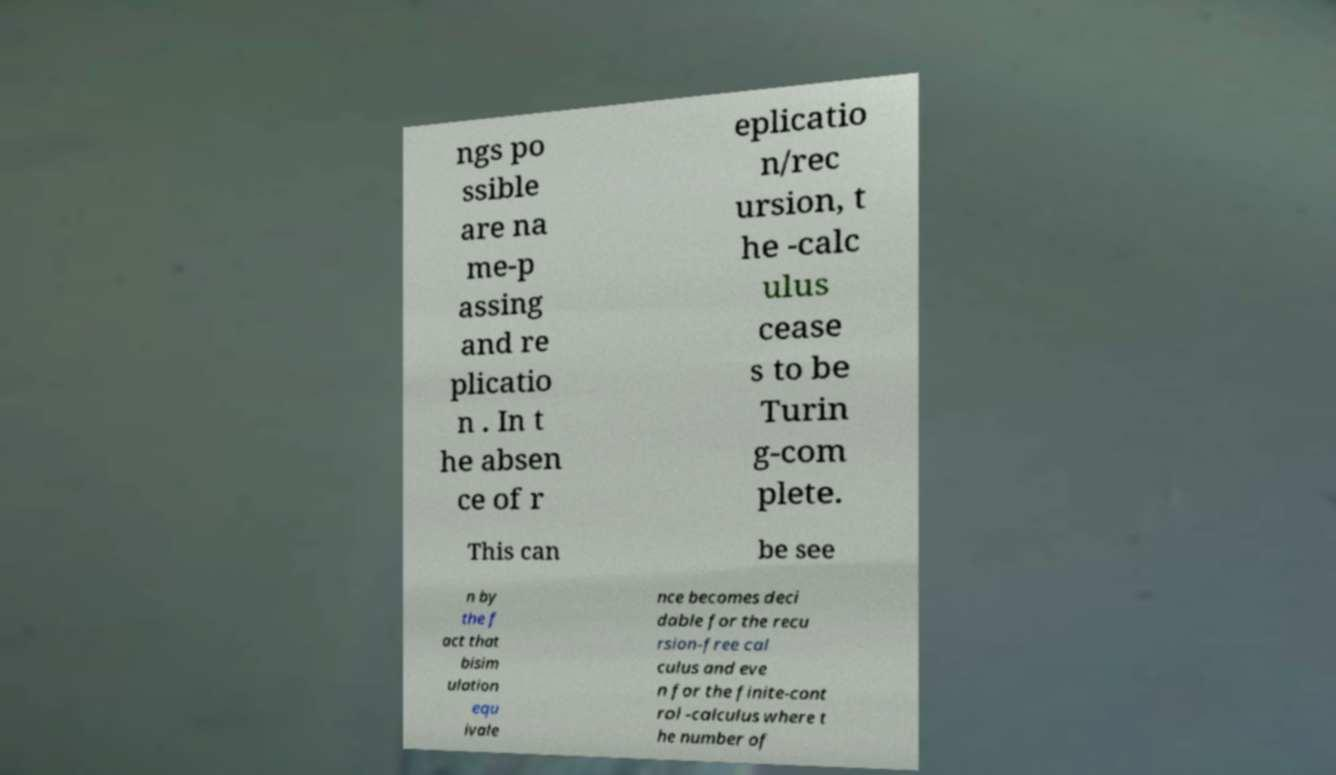Can you read and provide the text displayed in the image?This photo seems to have some interesting text. Can you extract and type it out for me? ngs po ssible are na me-p assing and re plicatio n . In t he absen ce of r eplicatio n/rec ursion, t he -calc ulus cease s to be Turin g-com plete. This can be see n by the f act that bisim ulation equ ivale nce becomes deci dable for the recu rsion-free cal culus and eve n for the finite-cont rol -calculus where t he number of 